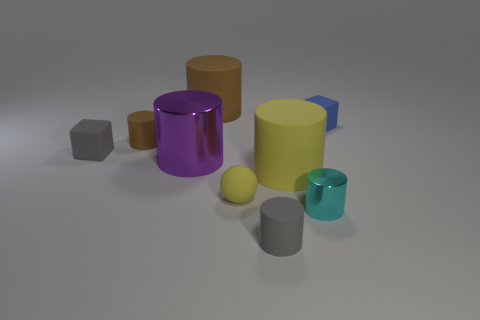Subtract all tiny brown matte cylinders. How many cylinders are left? 5 Add 1 tiny brown matte cylinders. How many objects exist? 10 Subtract all gray blocks. How many blocks are left? 1 Subtract all green blocks. How many brown cylinders are left? 2 Subtract all brown shiny cylinders. Subtract all yellow spheres. How many objects are left? 8 Add 6 brown cylinders. How many brown cylinders are left? 8 Add 2 purple cylinders. How many purple cylinders exist? 3 Subtract 1 yellow cylinders. How many objects are left? 8 Subtract all cylinders. How many objects are left? 3 Subtract all purple balls. Subtract all blue cubes. How many balls are left? 1 